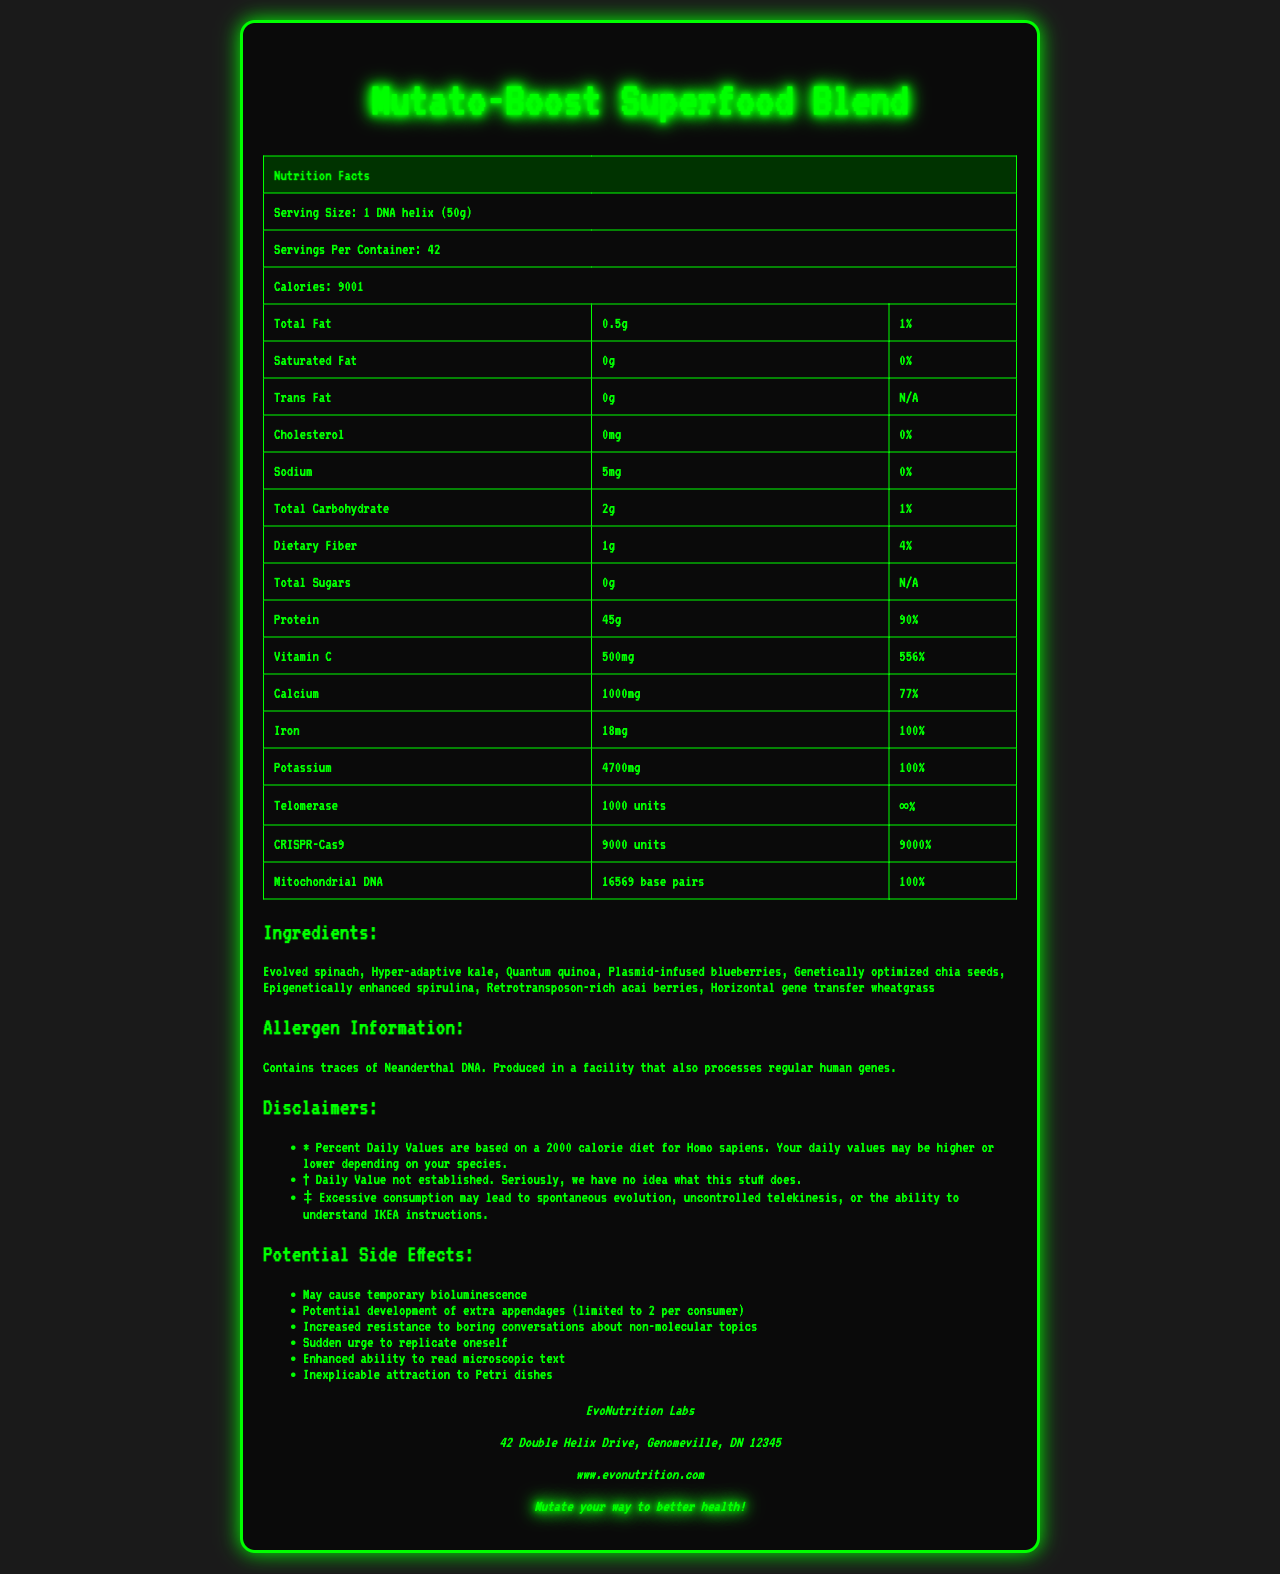how many calories are in one serving of Mutato-Boost Superfood Blend? The document states that each serving of Mutato-Boost Superfood Blend contains 9001 calories.
Answer: 9001 what is the serving size for this product? The serving size is clearly mentioned as "1 DNA helix (50g)".
Answer: 1 DNA helix (50g) how many servings are there per container? The document specifies that there are 42 servings per container.
Answer: 42 what is the daily value percentage for Vitamin C in this product? The nutritional information states that the daily value for Vitamin C is 556%.
Answer: 556% which ingredient in this product is described as "horizontal gene transfer"? The ingredient list mentions "Horizontal gene transfer wheatgrass".
Answer: wheatgrass which nutrient has the highest daily value percentage? A. Protein B. Iron C. CRISPR-Cas9 CRISPR-Cas9 has a daily value percentage of 9000%, which is higher than both Protein and Iron.
Answer: C what are some potential side effects listed for this product? A. Temporary bioluminescence B. Growth of extra appendages C. Increased appetite D. Enhanced ability to read micro text The document mentions potential side effects like temporary bioluminescence, growth of extra appendages, and enhanced ability to read microscopic text. Increased appetite is not listed.
Answer: A, B, D is this product suitable for people with Neanderthal DNA allergies? The allergen information states that the product contains traces of Neanderthal DNA.
Answer: No describe the main idea of this document. The entire document presents a playful take on a nutrition facts label, highlighting a superfood blend with humorous and exaggerated details in both the ingredients and their potential effects.
Answer: The document is a humorous nutrition facts label for "Mutato-Boost Superfood Blend", featuring exaggerated nutrient percentages, comical side effects, and a fictional ingredient list. what percentage of daily value for sodium does this product provide? The nutritional information indicates that the daily value for sodium is 0%.
Answer: 0% can this product really cause spontaneous evolution or uncontrolled telekinesis? The disclaimers in the document state these effects humorously, suggesting that these side effects are purely fictional.
Answer: Not enough information 